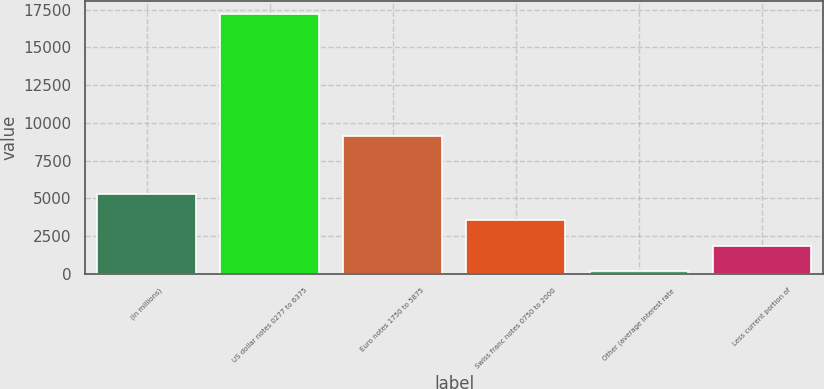Convert chart to OTSL. <chart><loc_0><loc_0><loc_500><loc_500><bar_chart><fcel>(in millions)<fcel>US dollar notes 0277 to 6375<fcel>Euro notes 1750 to 5875<fcel>Swiss franc notes 0750 to 2000<fcel>Other (average interest rate<fcel>Less current portion of<nl><fcel>5285.6<fcel>17229<fcel>9161<fcel>3579.4<fcel>167<fcel>1873.2<nl></chart> 